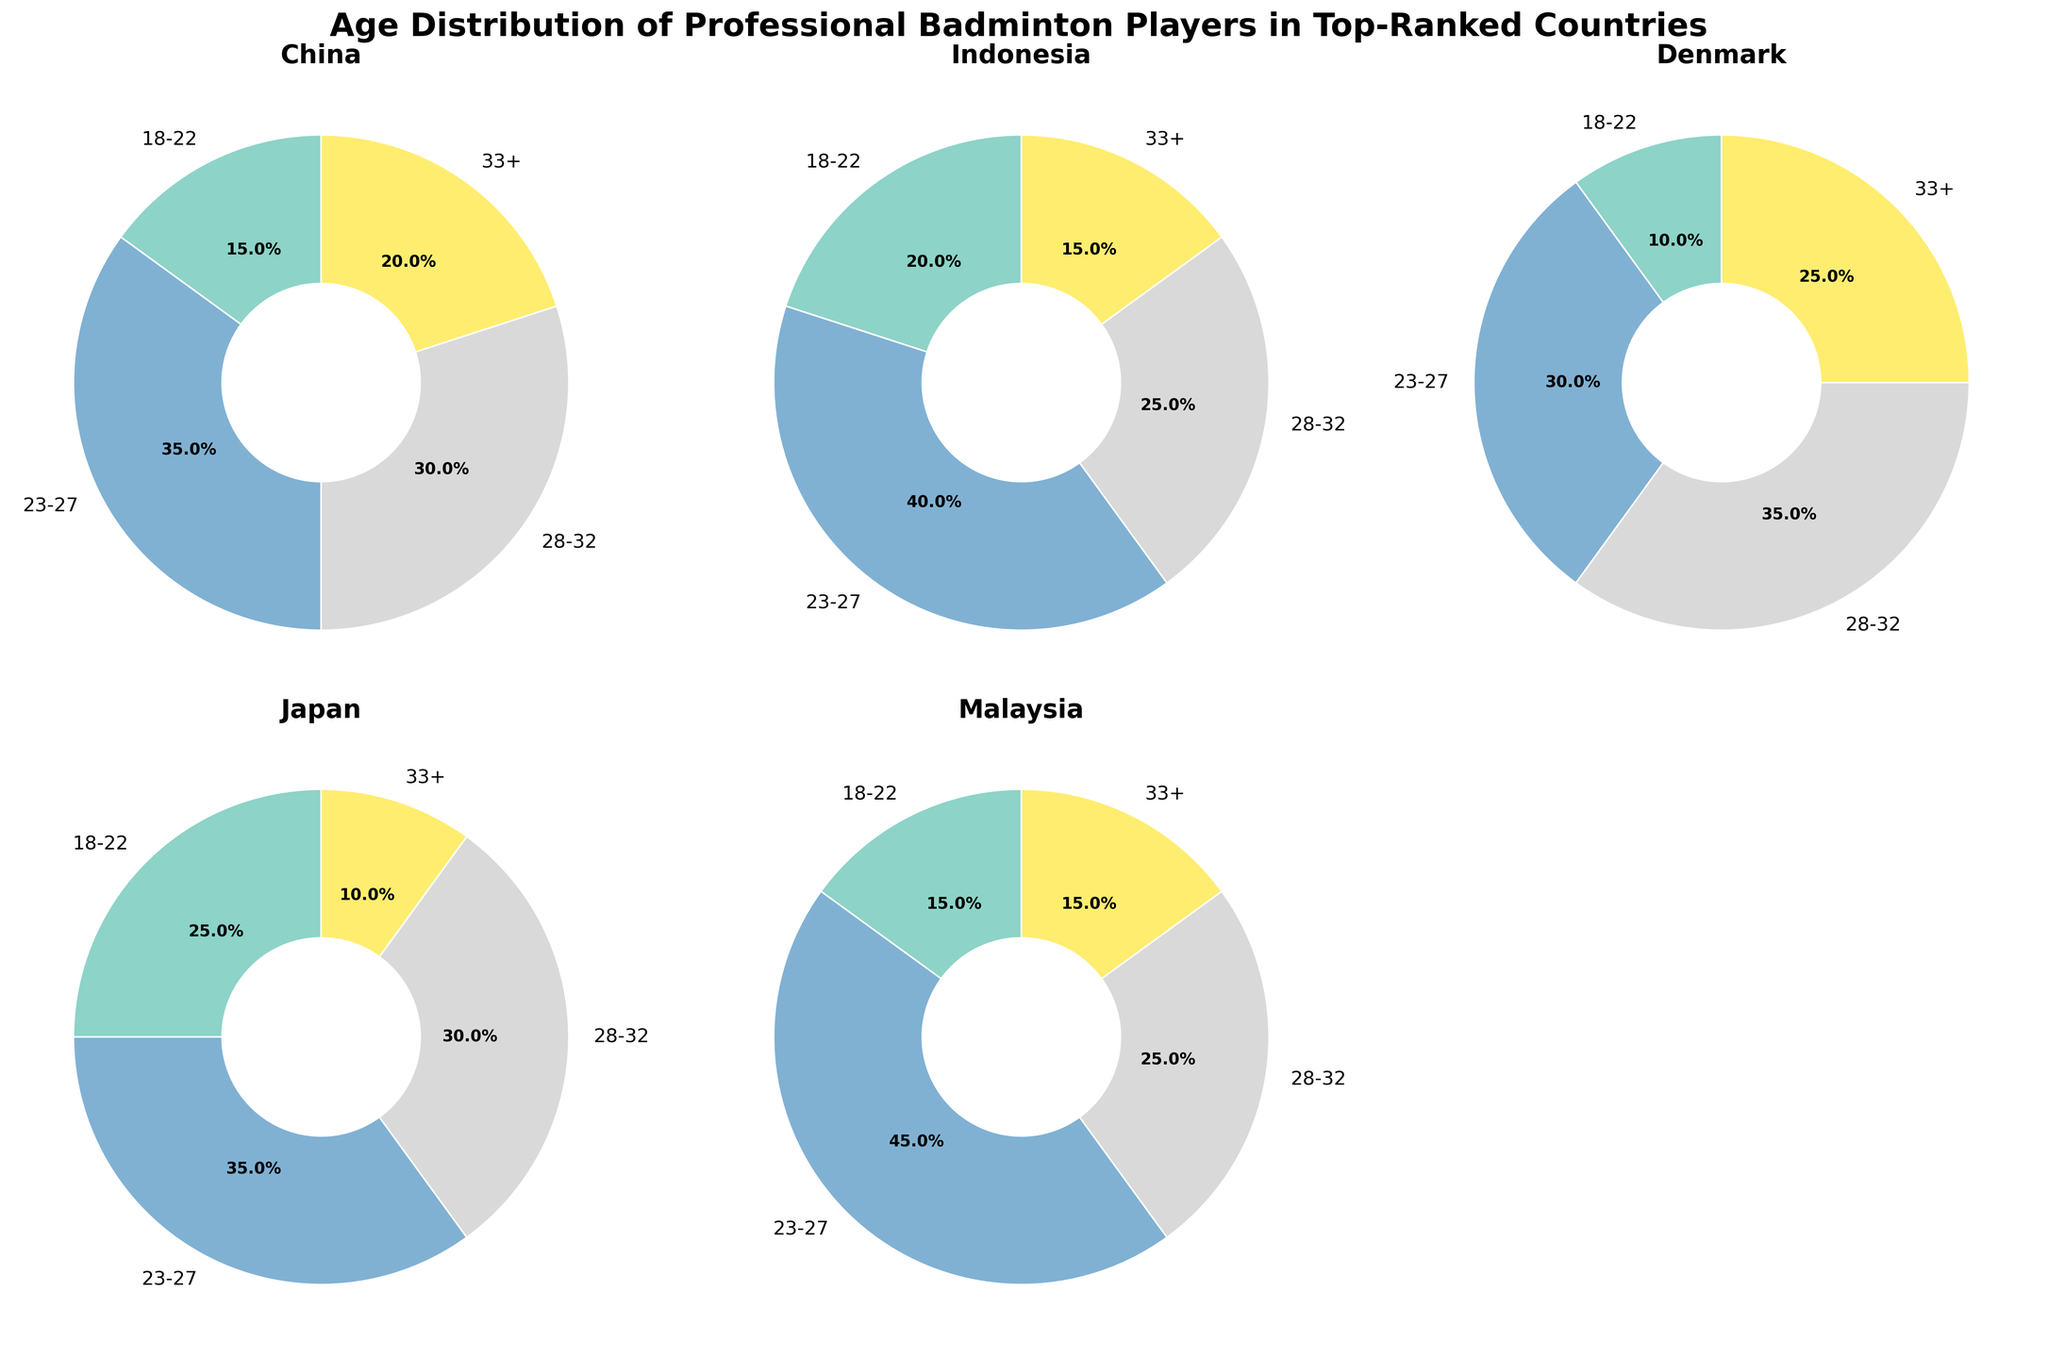What age group has the highest percentage of players in Indonesia? Looking at the pie chart for Indonesia, the largest segment corresponds to the 23-27 age group.
Answer: 23-27 Which country has the highest percentage of players aged 33+? By comparing all the pie charts, Denmark has the highest percentage of players aged 33+ with a segment size of 25%.
Answer: Denmark What is the total percentage of players aged 18-22 across all countries? Summing the percentages: China 15%, Indonesia 20%, Denmark 10%, Japan 25%, and Malaysia 15% gives 15 + 20 + 10 + 25 + 15 = 85%.
Answer: 85% Which age group in Japan has the smallest representation? The pie chart for Japan shows the smallest segment corresponds to the 33+ age group with 10%.
Answer: 33+ How does the percentage of 23-27 age group players in Malaysia compare with China? The 23-27 age group has 45% in Malaysia and 35% in China. 45% is greater than 35%.
Answer: Malaysia has a higher percentage What is the difference in percentage between the 23-27 age group and 28-32 age group in Denmark? For Denmark, the percentages are 30% (23-27) and 35% (28-32). The difference is 35 - 30 = 5%.
Answer: 5% How do the percentages of the 28-32 age group in China and Japan compare? The pie charts show both China and Japan have 30% in the 28-32 age group.
Answer: Equal In which country are players under 23 most represented? The pie charts show that Japan has the highest percentage (25%) for the 18-22 age group.
Answer: Japan Find the average percentage of players aged 33+ across all countries. Adding the percentages: China 20%, Indonesia 15%, Denmark 25%, Japan 10%, Malaysia 15%, and dividing by 5: (20 + 15 + 25 + 10 + 15)/5 = 85/5 = 17%.
Answer: 17% Which two countries have the most and least balanced age distribution? The pie chart that shows the smallest range between the largest and smallest percentages suggests a balanced distribution, while the largest range indicates the least balanced distribution. China appears least balanced ranging from 15% to 35% alongside Malaysia whereas Denmark ranging  from 10% to 35%.
Answer: Most balanced: Denmark, Least balanced: Malaysia 